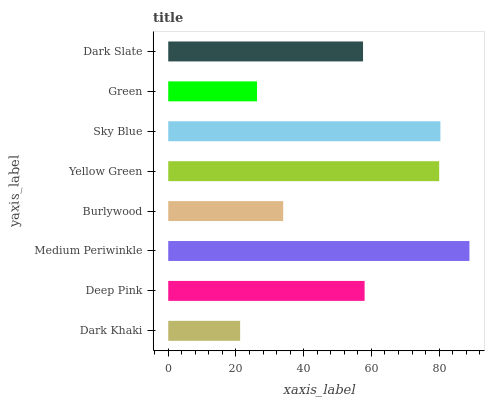Is Dark Khaki the minimum?
Answer yes or no. Yes. Is Medium Periwinkle the maximum?
Answer yes or no. Yes. Is Deep Pink the minimum?
Answer yes or no. No. Is Deep Pink the maximum?
Answer yes or no. No. Is Deep Pink greater than Dark Khaki?
Answer yes or no. Yes. Is Dark Khaki less than Deep Pink?
Answer yes or no. Yes. Is Dark Khaki greater than Deep Pink?
Answer yes or no. No. Is Deep Pink less than Dark Khaki?
Answer yes or no. No. Is Deep Pink the high median?
Answer yes or no. Yes. Is Dark Slate the low median?
Answer yes or no. Yes. Is Green the high median?
Answer yes or no. No. Is Medium Periwinkle the low median?
Answer yes or no. No. 